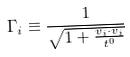Convert formula to latex. <formula><loc_0><loc_0><loc_500><loc_500>\Gamma _ { i } \equiv \frac { 1 } { \sqrt { 1 + \frac { v _ { i } \cdot v _ { i } } { t ^ { 0 } } } }</formula> 